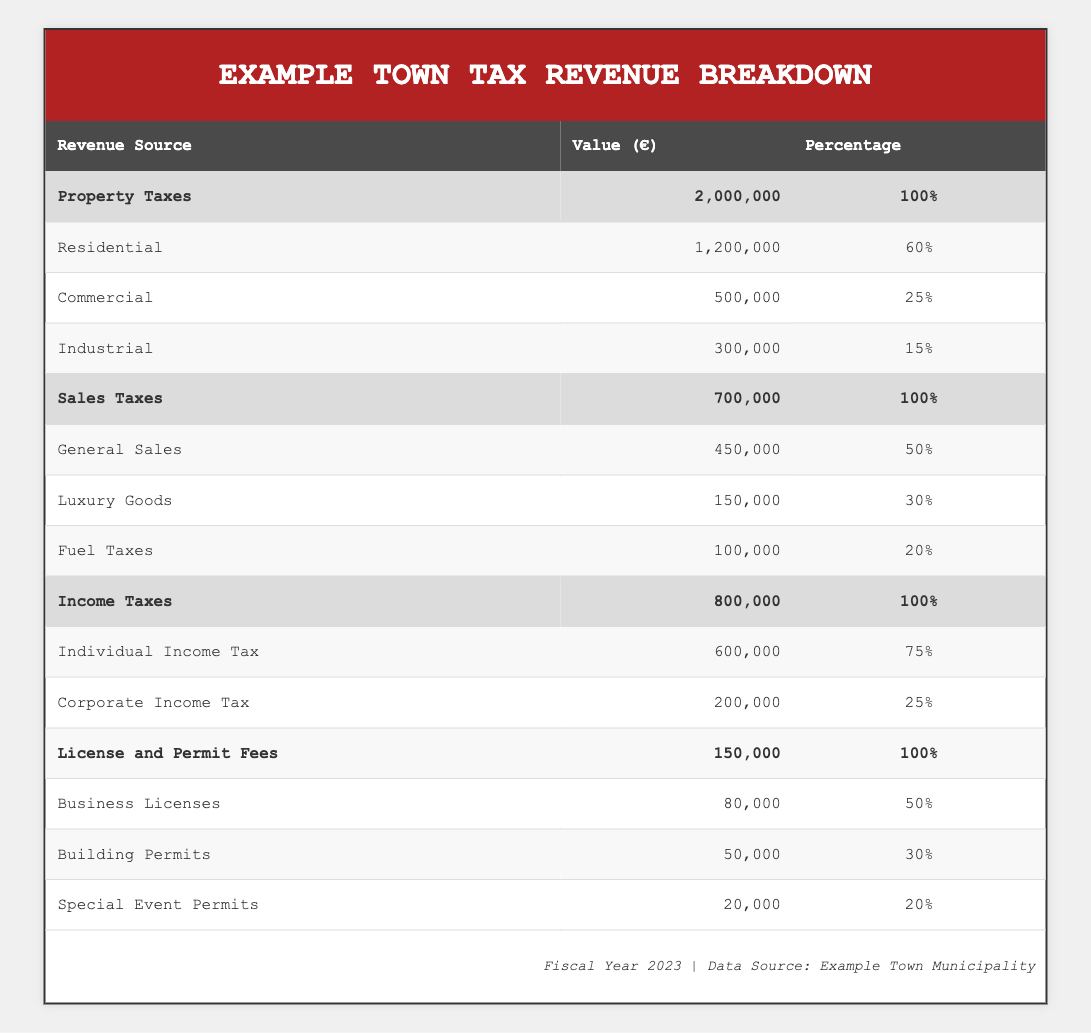What is the total value of Property Taxes? The total for Property Taxes is shown in the first row under Revenue Source. The value is 2,000,000.
Answer: 2,000,000 What percentage of Sales Taxes comes from General Sales? The table indicates that General Sales accounts for 50% of total Sales Taxes, which is 100%.
Answer: 50% Is the revenue from Corporate Income Tax higher than that from Business Licenses? The value from Corporate Income Tax is 200,000 while Business Licenses generate 80,000. Thus, the revenue from Corporate Income Tax is indeed higher.
Answer: Yes What is the combined value of all Income Tax sources? The values from Individual Income Tax (600,000) and Corporate Income Tax (200,000) are summed: 600,000 + 200,000 = 800,000.
Answer: 800,000 What percentage of total License and Permit Fees does Business Licenses contribute? Business Licenses generate 80,000 out of a total of 150,000 for License and Permit Fees. The percentage can be calculated as (80,000 / 150,000) * 100 = 53.33%.
Answer: 53.33% Which revenue source contributes the least to the overall tax revenue? Looking at the overall totals, the least value comes from Special Event Permits at 20,000.
Answer: Special Event Permits What is the difference in value between Individual Income Tax and Sales Taxes from Luxury Goods? Individual Income Tax is 600,000, and Luxury Goods sales contribute 150,000. The difference is calculated as 600,000 - 150,000 = 450,000.
Answer: 450,000 What is the total revenue generated from all Commercial property taxes? The total value from Commercial property taxes is 500,000 as reported in the relevant section.
Answer: 500,000 Does the municipality receive more revenue from Residential property taxes than from General Sales? Residential property taxes are 1,200,000 while General Sales are 450,000. Since 1,200,000 is greater than 450,000, the municipality receives more from Residential property taxes.
Answer: Yes 